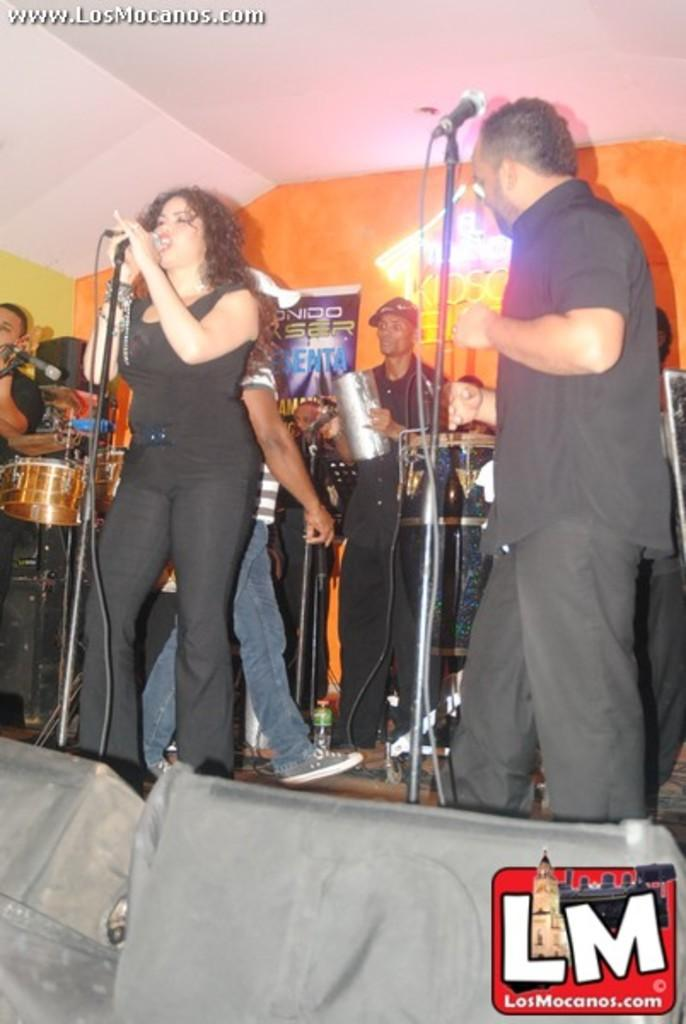Who are the people in the image? There is a woman and a man in the image. What are the woman and man doing in the image? Both the woman and man are singing on a microphone. Are there any other musicians in the image? Yes, there are people playing music instruments in the image. What type of flower is being offered by the woman in the image? There is no flower present in the image; the woman is singing on a microphone. What scientific theory is being discussed by the man in the image? There is no discussion of a scientific theory in the image; the man is singing on a microphone. 